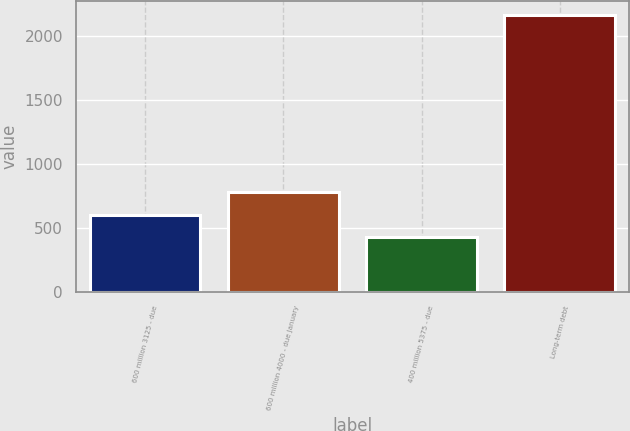Convert chart to OTSL. <chart><loc_0><loc_0><loc_500><loc_500><bar_chart><fcel>600 million 3125 - due<fcel>600 million 4000 - due January<fcel>400 million 5375 - due<fcel>Long-term debt<nl><fcel>601.87<fcel>775.14<fcel>428.6<fcel>2161.3<nl></chart> 